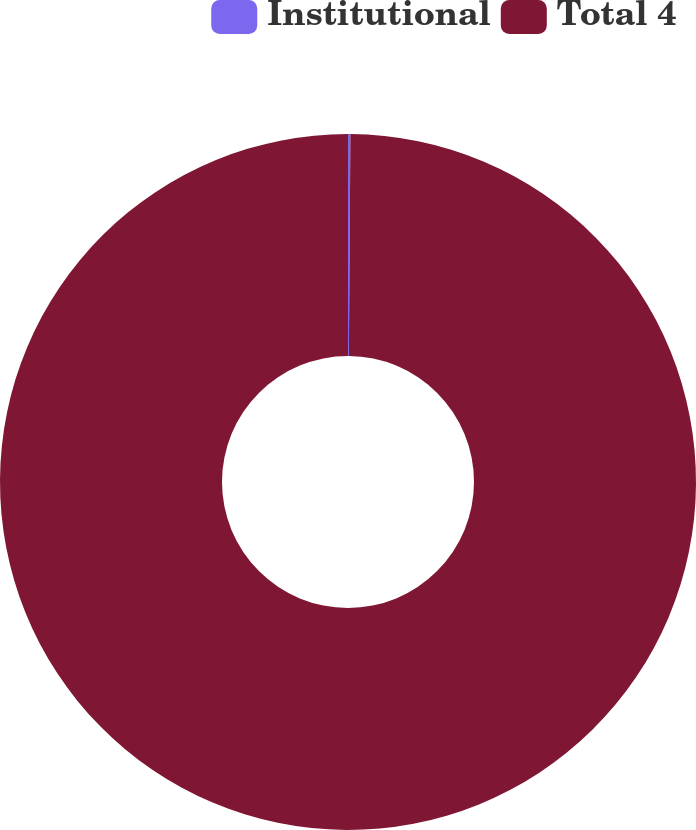Convert chart to OTSL. <chart><loc_0><loc_0><loc_500><loc_500><pie_chart><fcel>Institutional<fcel>Total 4<nl><fcel>0.11%<fcel>99.89%<nl></chart> 